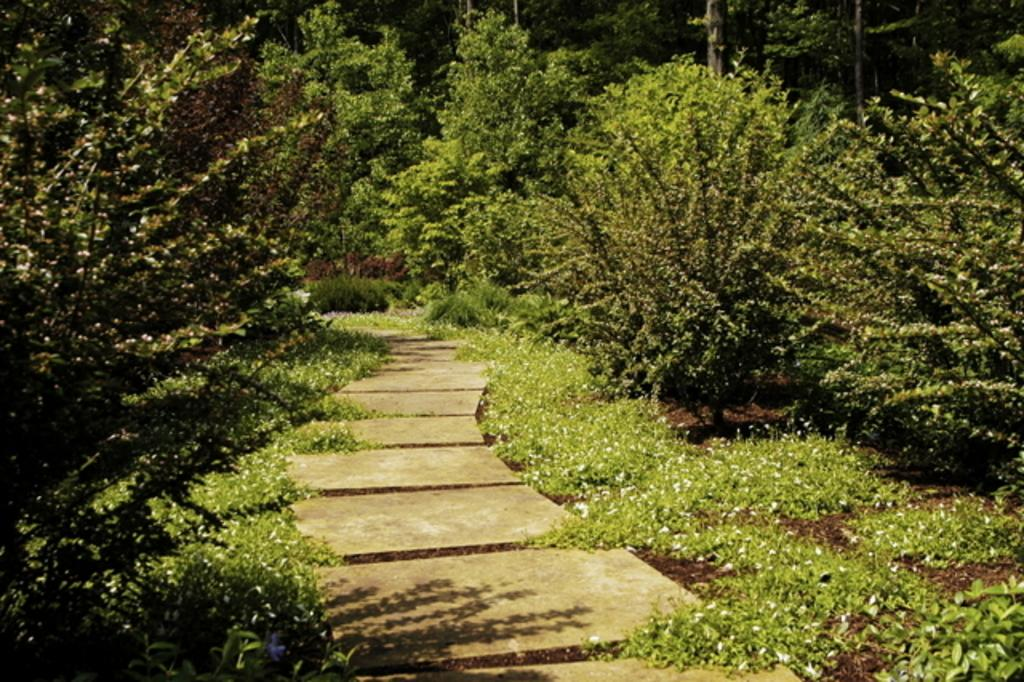What is the main feature of the image? There is a path in the image. What type of vegetation can be seen along the path? There is grass visible in the image. What can be seen in the distance in the image? There are trees in the background of the image. Can you see a baby riding a horse along the path in the image? There is no baby or horse present in the image; it only features a path, grass, and trees in the background. 